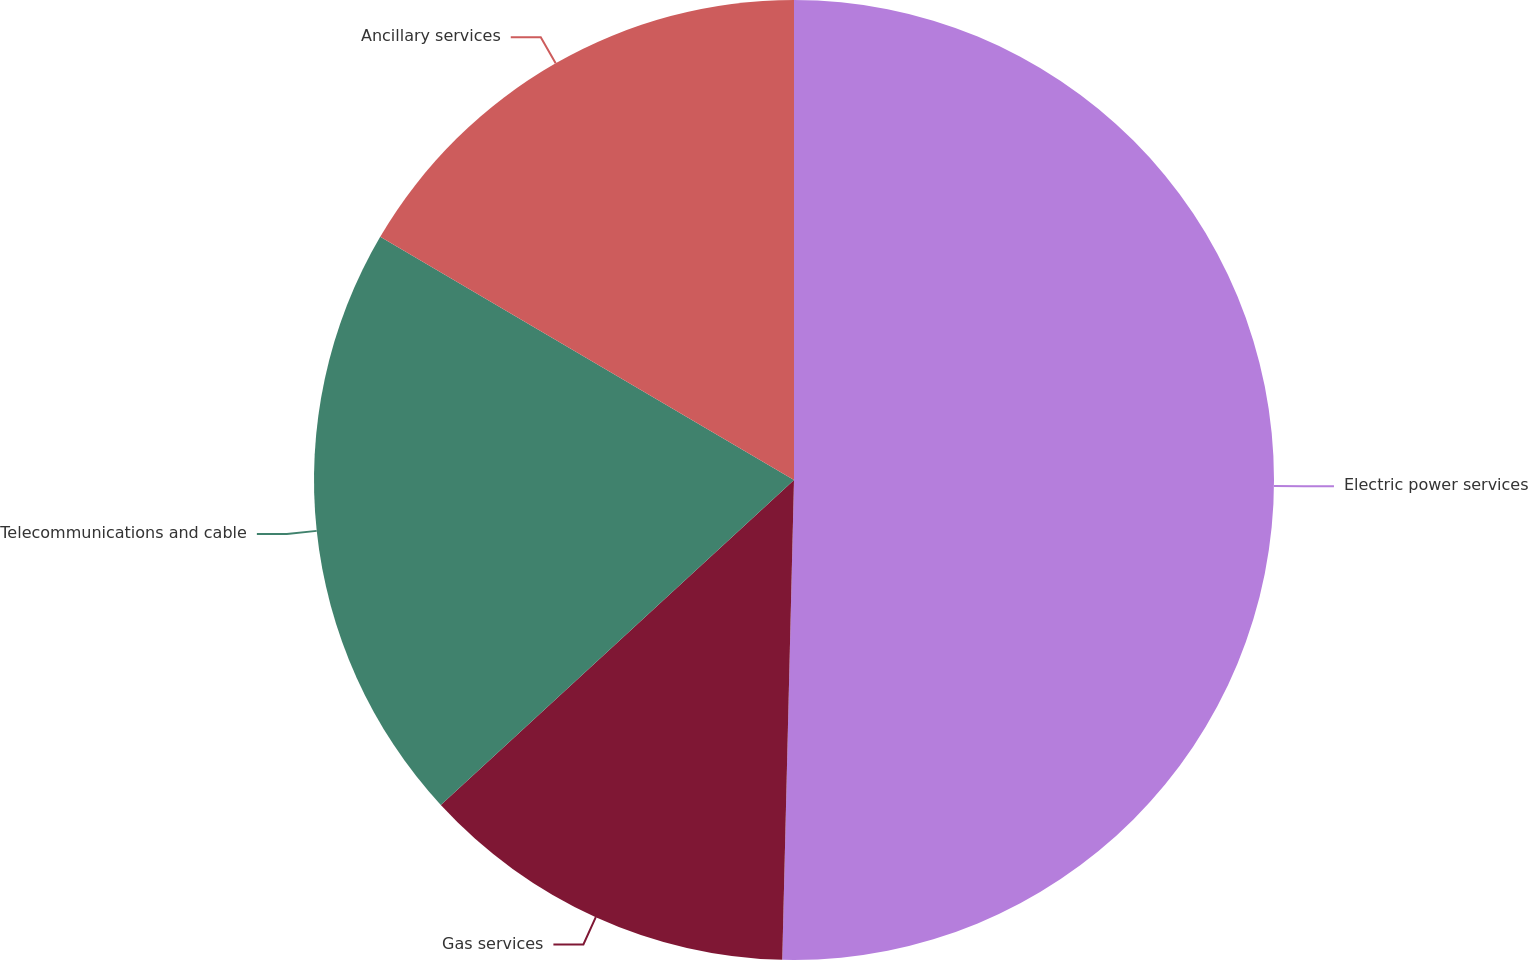<chart> <loc_0><loc_0><loc_500><loc_500><pie_chart><fcel>Electric power services<fcel>Gas services<fcel>Telecommunications and cable<fcel>Ancillary services<nl><fcel>50.39%<fcel>12.77%<fcel>20.3%<fcel>16.54%<nl></chart> 